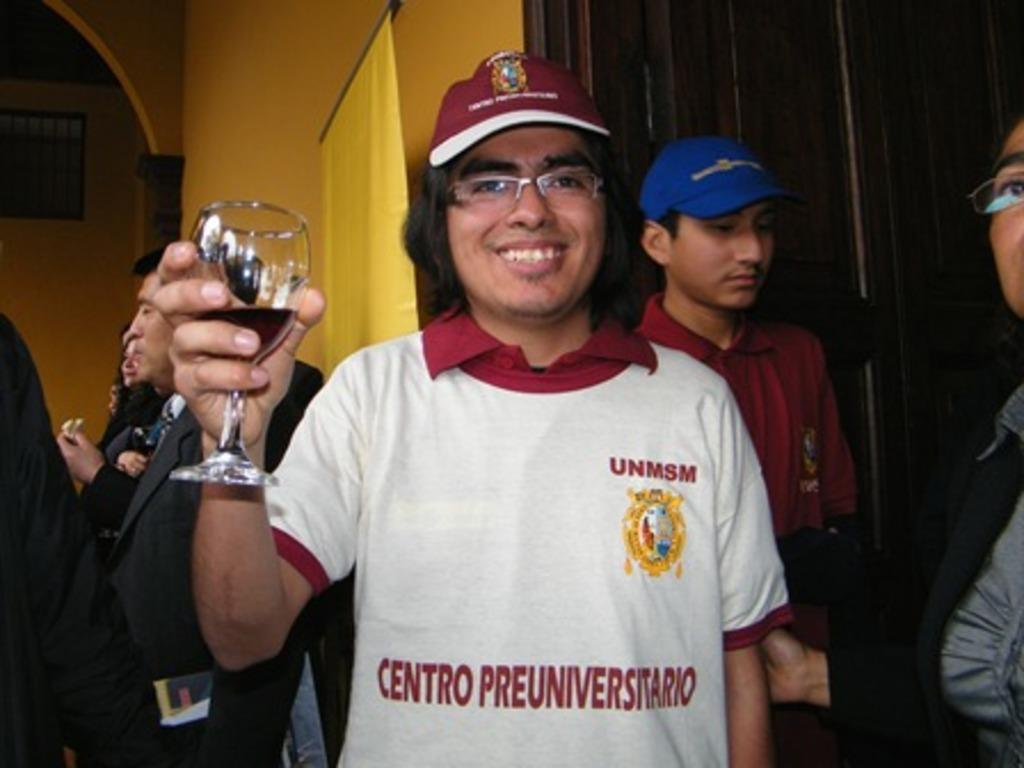What is the man holding in the image? The man is holding a glass with liquid in the image. Can you describe the man's appearance? The man is wearing spectacles and a cap in the image. What is the position of the persons in the image? The persons are standing in the image. What color is the banner in the image? There is a yellow banner in the image. What is the color of the wall in the image? The wall is yellow in the image. What type of crime can be seen being committed in the image? There is no crime being committed in the image; it only shows a man holding a glass with liquid and wearing spectacles and a cap. 